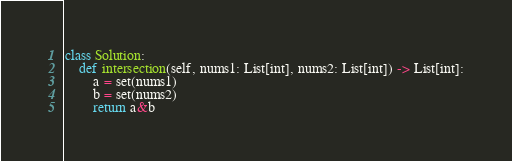<code> <loc_0><loc_0><loc_500><loc_500><_Python_>class Solution:
    def intersection(self, nums1: List[int], nums2: List[int]) -> List[int]:
        a = set(nums1)
        b = set(nums2)
        return a&b</code> 